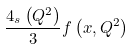Convert formula to latex. <formula><loc_0><loc_0><loc_500><loc_500>\frac { 4 _ { s } \left ( Q ^ { 2 } \right ) } { 3 } f \left ( x , Q ^ { 2 } \right )</formula> 